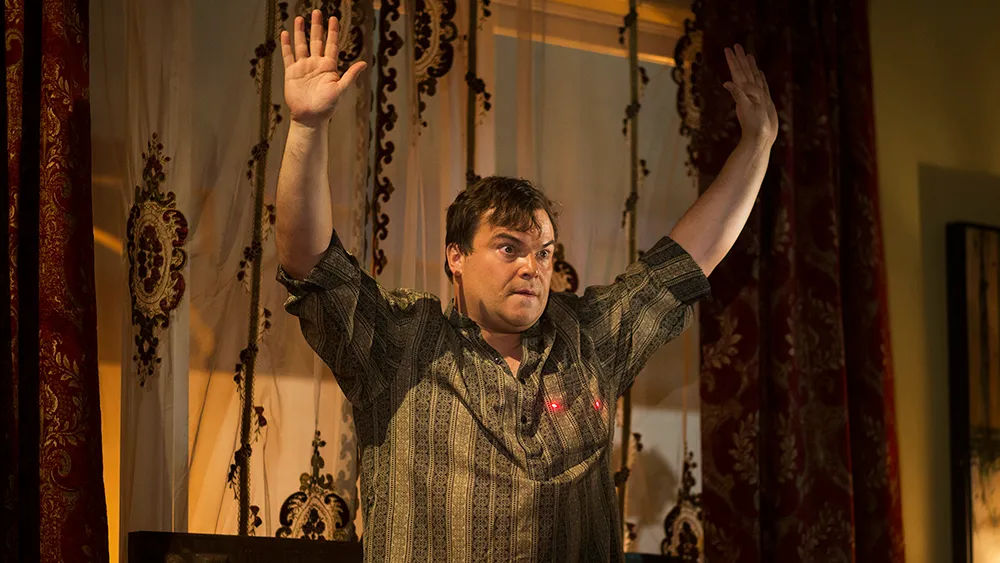Can you describe the setting and how it contributes to the overall mood of the image? The setting features opulent decor with rich, heavy curtains and a grand chandelier, which frame the man centrally on stage. This opulence suggests a formal or dramatic scenario, likely a theatrical performance, that enhances the emotional expression captured. The luxurious surroundings contribute to a heightened sense of drama and grandeur, emphasizing the significance of the moment depicted. 